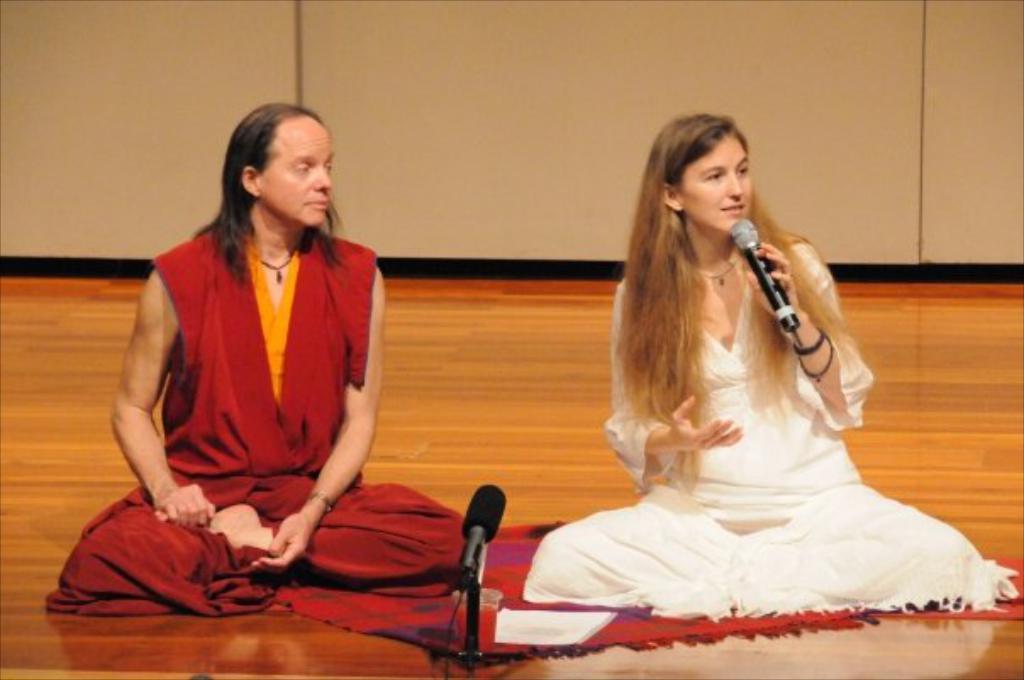Describe this image in one or two sentences. In the center we can see two persons were sitting on the floor. The woman she is holding microphone,in center we can see another microphone. And coming to background there is a wall. 